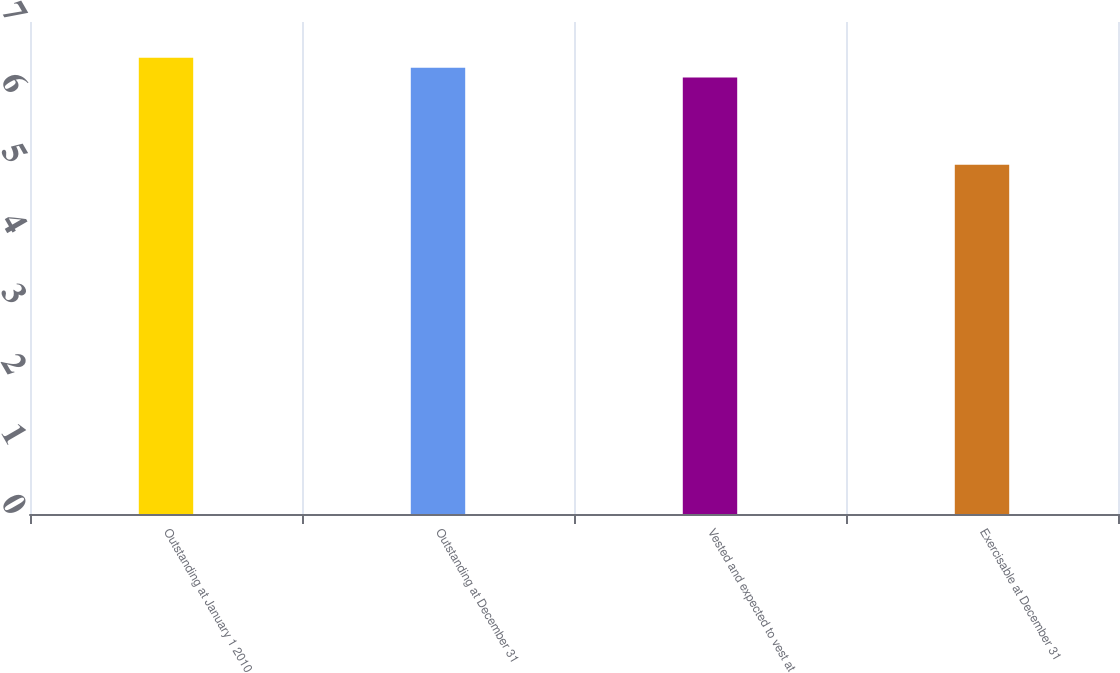<chart> <loc_0><loc_0><loc_500><loc_500><bar_chart><fcel>Outstanding at January 1 2010<fcel>Outstanding at December 31<fcel>Vested and expected to vest at<fcel>Exercisable at December 31<nl><fcel>6.49<fcel>6.35<fcel>6.21<fcel>4.97<nl></chart> 